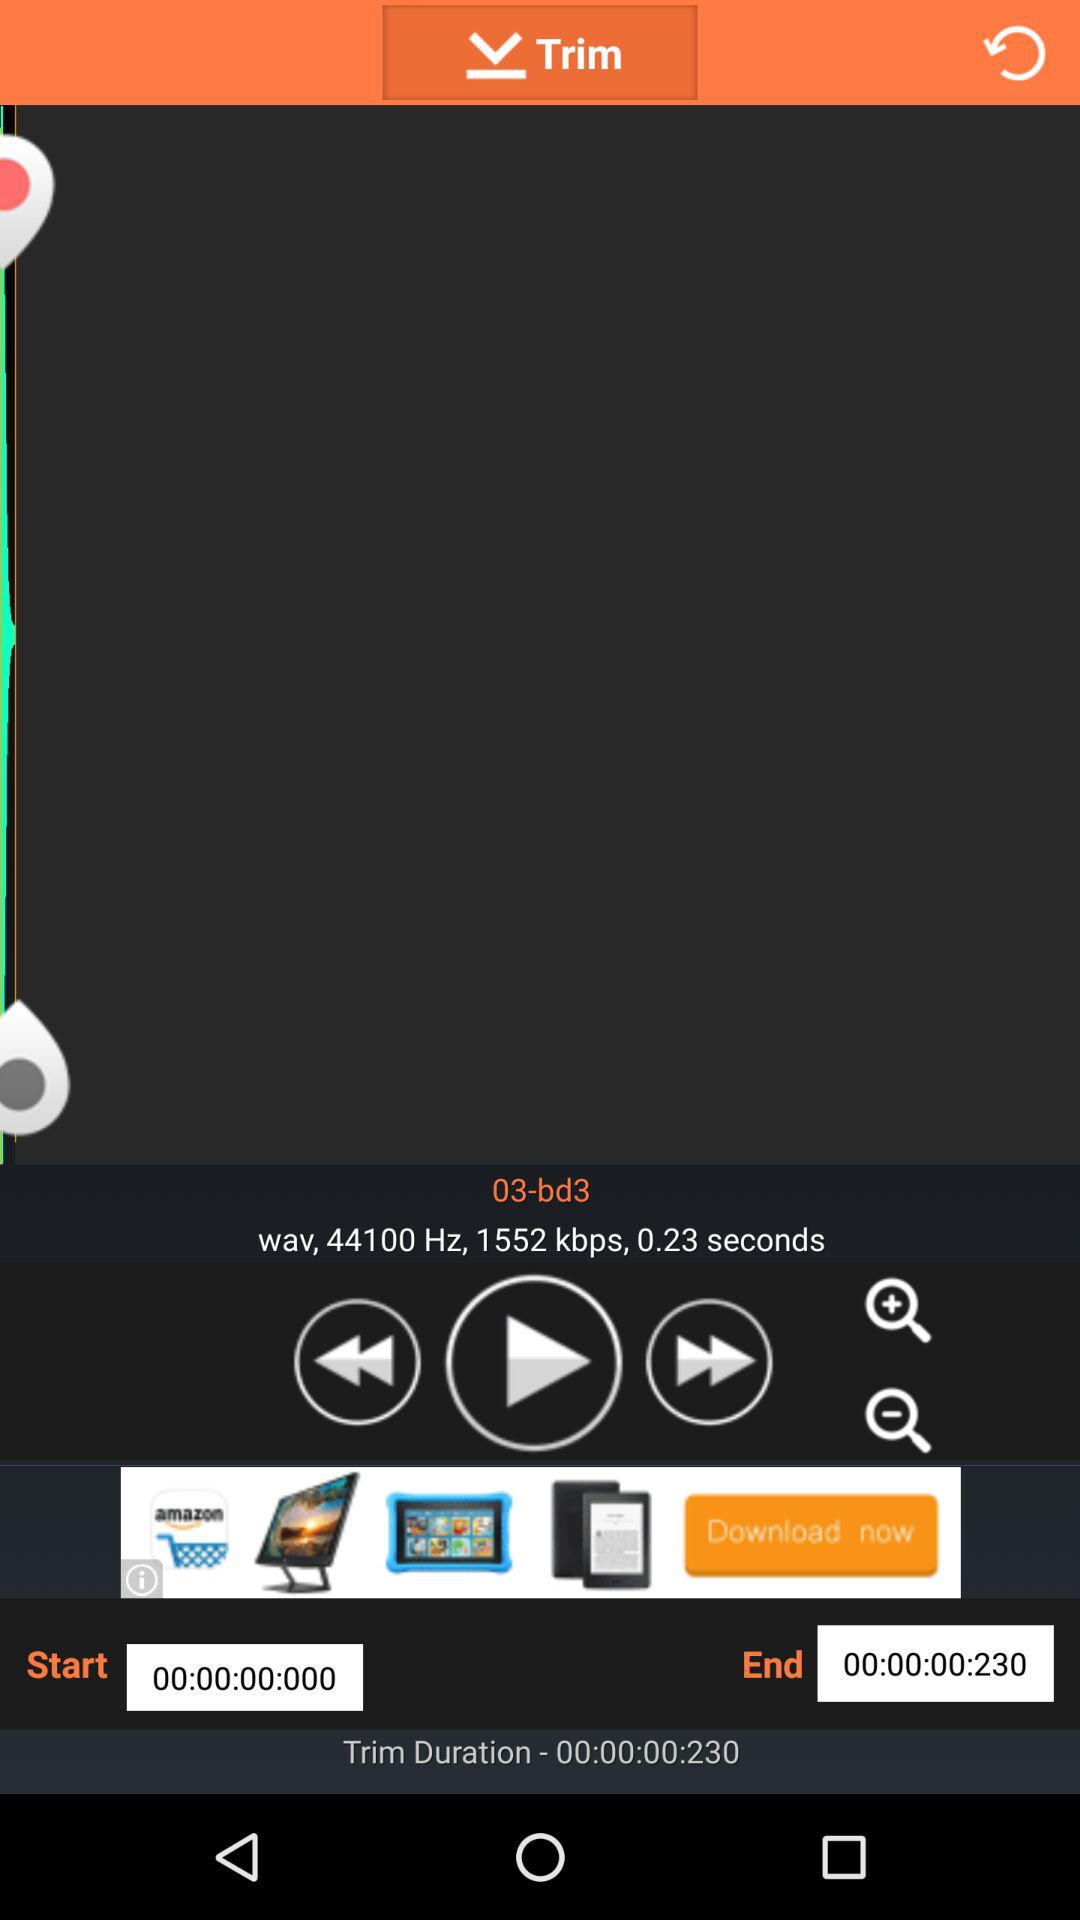What is the trim duration of the song? The trim duration of the song is 0.23 seconds. 